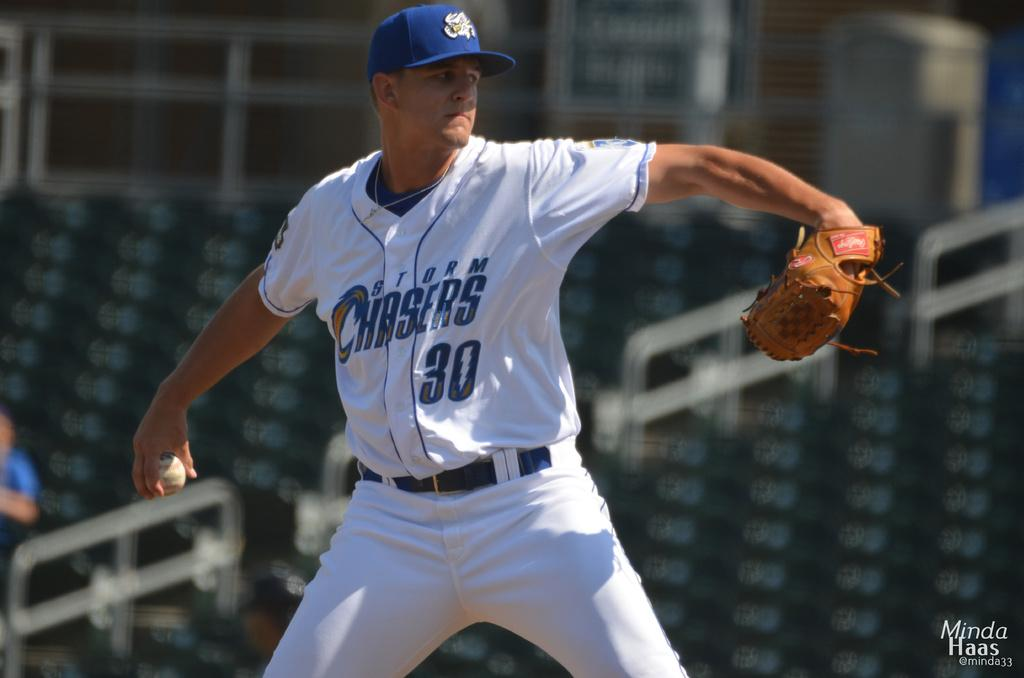Provide a one-sentence caption for the provided image. The pitcher from the Storm Chasers team is ready to throw the baseball. 